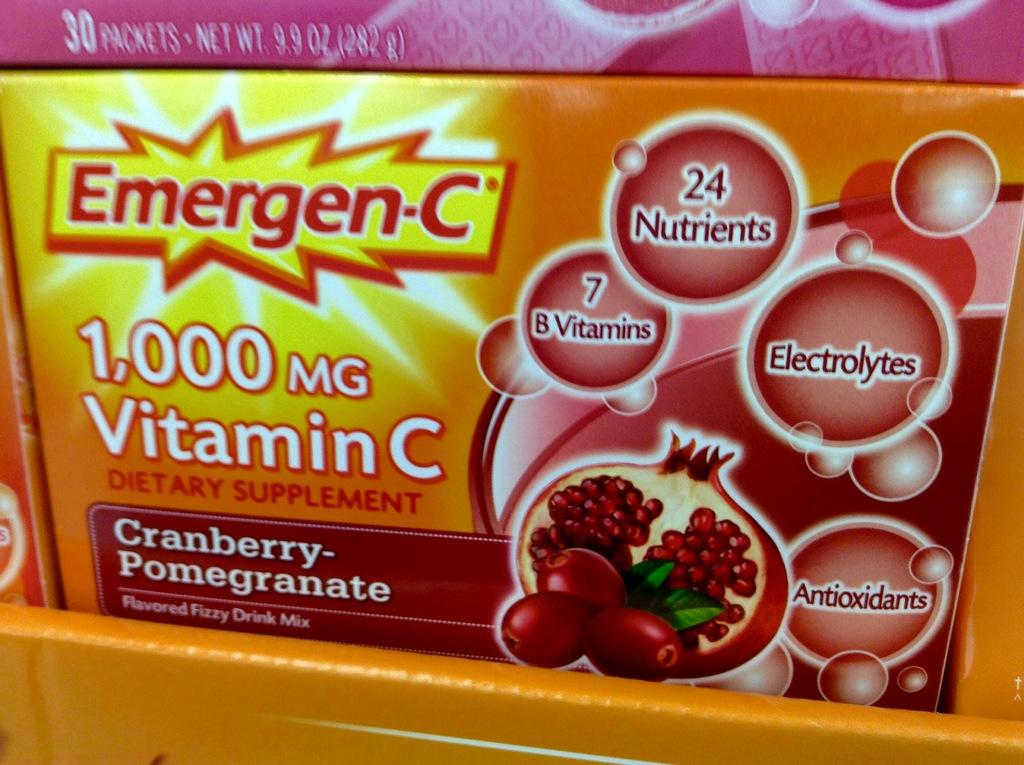What objects are present in the image? There are boxes in the image. What is written or printed on the boxes? There is text on the boxes. What else can be seen on the boxes besides the text? There are images on the boxes. How many sisters can be seen in the image? There are no sisters present in the image; it only features boxes with text and images. 